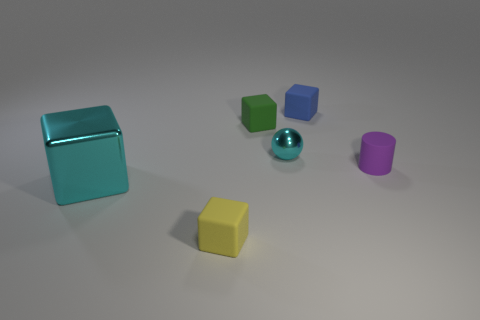There is a tiny shiny thing that is the same color as the shiny cube; what shape is it?
Offer a very short reply. Sphere. What is the shape of the metal object that is right of the cyan thing that is to the left of the green matte cube?
Your response must be concise. Sphere. Is there any other thing that has the same color as the large cube?
Ensure brevity in your answer.  Yes. There is a metallic thing that is in front of the cyan thing to the right of the green matte block; is there a tiny cyan metallic object that is in front of it?
Make the answer very short. No. There is a small block in front of the tiny cyan thing; is it the same color as the metallic object that is in front of the purple matte cylinder?
Offer a very short reply. No. What material is the yellow object that is the same size as the purple rubber cylinder?
Keep it short and to the point. Rubber. There is a metal object to the left of the cyan metal object behind the tiny thing that is on the right side of the small blue cube; what size is it?
Provide a succinct answer. Large. What number of other objects are the same material as the small cyan sphere?
Offer a terse response. 1. There is a cyan shiny object on the right side of the big cyan thing; how big is it?
Give a very brief answer. Small. How many rubber objects are in front of the cyan metallic sphere and right of the tiny green cube?
Give a very brief answer. 1. 